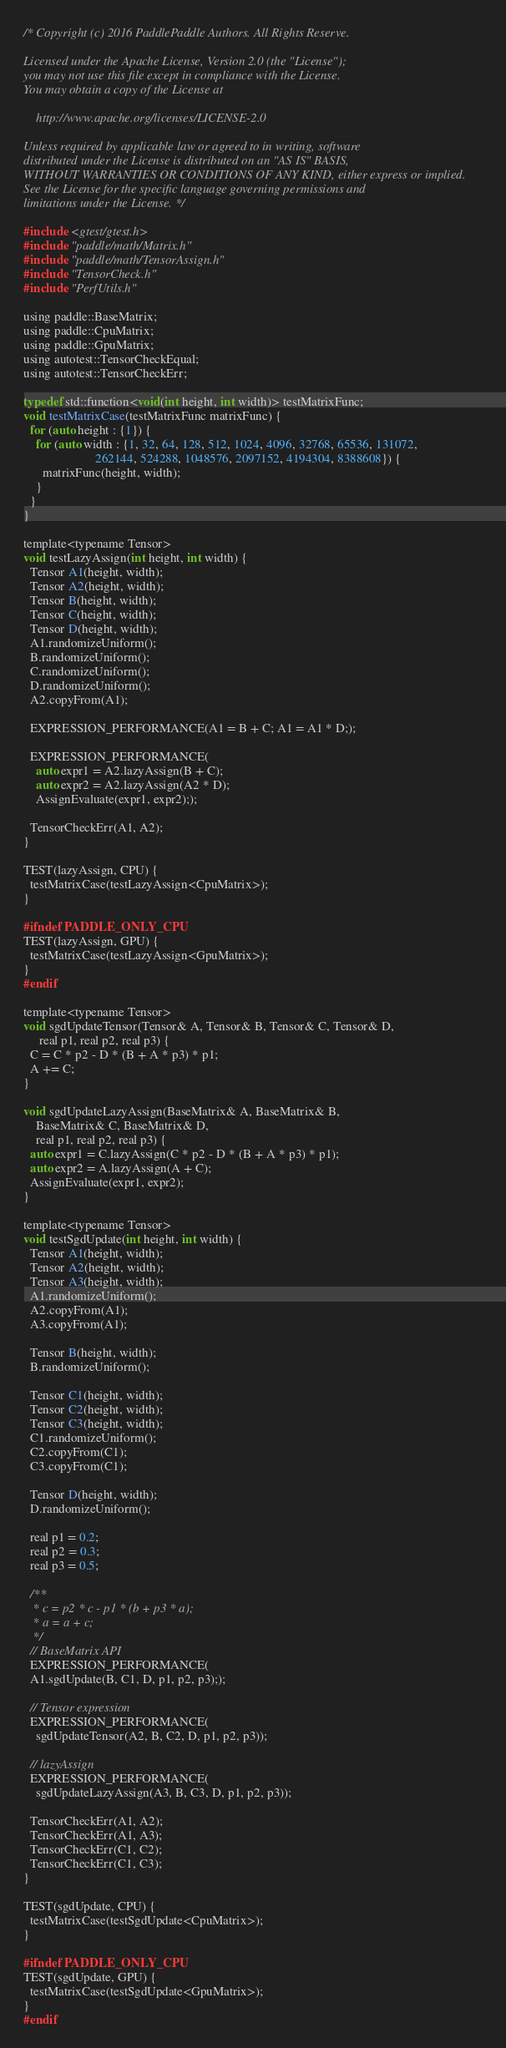Convert code to text. <code><loc_0><loc_0><loc_500><loc_500><_Cuda_>/* Copyright (c) 2016 PaddlePaddle Authors. All Rights Reserve.

Licensed under the Apache License, Version 2.0 (the "License");
you may not use this file except in compliance with the License.
You may obtain a copy of the License at

    http://www.apache.org/licenses/LICENSE-2.0

Unless required by applicable law or agreed to in writing, software
distributed under the License is distributed on an "AS IS" BASIS,
WITHOUT WARRANTIES OR CONDITIONS OF ANY KIND, either express or implied.
See the License for the specific language governing permissions and
limitations under the License. */

#include <gtest/gtest.h>
#include "paddle/math/Matrix.h"
#include "paddle/math/TensorAssign.h"
#include "TensorCheck.h"
#include "PerfUtils.h"

using paddle::BaseMatrix;
using paddle::CpuMatrix;
using paddle::GpuMatrix;
using autotest::TensorCheckEqual;
using autotest::TensorCheckErr;

typedef std::function<void(int height, int width)> testMatrixFunc;
void testMatrixCase(testMatrixFunc matrixFunc) {
  for (auto height : {1}) {
    for (auto width : {1, 32, 64, 128, 512, 1024, 4096, 32768, 65536, 131072,
                       262144, 524288, 1048576, 2097152, 4194304, 8388608}) {
      matrixFunc(height, width);
    }
  }
}

template<typename Tensor>
void testLazyAssign(int height, int width) {
  Tensor A1(height, width);
  Tensor A2(height, width);
  Tensor B(height, width);
  Tensor C(height, width);
  Tensor D(height, width);
  A1.randomizeUniform();
  B.randomizeUniform();
  C.randomizeUniform();
  D.randomizeUniform();
  A2.copyFrom(A1);

  EXPRESSION_PERFORMANCE(A1 = B + C; A1 = A1 * D;);

  EXPRESSION_PERFORMANCE(
    auto expr1 = A2.lazyAssign(B + C);
    auto expr2 = A2.lazyAssign(A2 * D);
    AssignEvaluate(expr1, expr2););

  TensorCheckErr(A1, A2);
}

TEST(lazyAssign, CPU) {
  testMatrixCase(testLazyAssign<CpuMatrix>);
}

#ifndef PADDLE_ONLY_CPU
TEST(lazyAssign, GPU) {
  testMatrixCase(testLazyAssign<GpuMatrix>);
}
#endif

template<typename Tensor>
void sgdUpdateTensor(Tensor& A, Tensor& B, Tensor& C, Tensor& D,
     real p1, real p2, real p3) {
  C = C * p2 - D * (B + A * p3) * p1;
  A += C;
}

void sgdUpdateLazyAssign(BaseMatrix& A, BaseMatrix& B,
    BaseMatrix& C, BaseMatrix& D,
    real p1, real p2, real p3) {
  auto expr1 = C.lazyAssign(C * p2 - D * (B + A * p3) * p1);
  auto expr2 = A.lazyAssign(A + C);
  AssignEvaluate(expr1, expr2);
}

template<typename Tensor>
void testSgdUpdate(int height, int width) {
  Tensor A1(height, width);
  Tensor A2(height, width);
  Tensor A3(height, width);
  A1.randomizeUniform();
  A2.copyFrom(A1);
  A3.copyFrom(A1);

  Tensor B(height, width);
  B.randomizeUniform();

  Tensor C1(height, width);
  Tensor C2(height, width);
  Tensor C3(height, width);
  C1.randomizeUniform();
  C2.copyFrom(C1);
  C3.copyFrom(C1);

  Tensor D(height, width);
  D.randomizeUniform();

  real p1 = 0.2;
  real p2 = 0.3;
  real p3 = 0.5;

  /**
   * c = p2 * c - p1 * (b + p3 * a);
   * a = a + c;
   */
  // BaseMatrix API
  EXPRESSION_PERFORMANCE(
  A1.sgdUpdate(B, C1, D, p1, p2, p3););

  // Tensor expression
  EXPRESSION_PERFORMANCE(
    sgdUpdateTensor(A2, B, C2, D, p1, p2, p3));

  // lazyAssign
  EXPRESSION_PERFORMANCE(
    sgdUpdateLazyAssign(A3, B, C3, D, p1, p2, p3));

  TensorCheckErr(A1, A2);
  TensorCheckErr(A1, A3);
  TensorCheckErr(C1, C2);
  TensorCheckErr(C1, C3);
}

TEST(sgdUpdate, CPU) {
  testMatrixCase(testSgdUpdate<CpuMatrix>);
}

#ifndef PADDLE_ONLY_CPU
TEST(sgdUpdate, GPU) {
  testMatrixCase(testSgdUpdate<GpuMatrix>);
}
#endif
</code> 